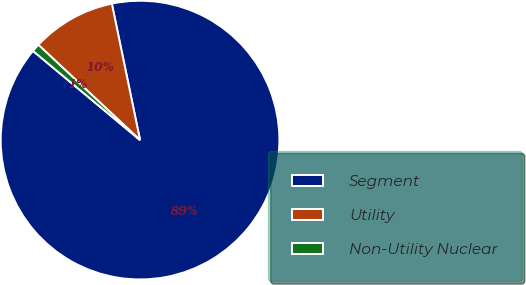Convert chart to OTSL. <chart><loc_0><loc_0><loc_500><loc_500><pie_chart><fcel>Segment<fcel>Utility<fcel>Non-Utility Nuclear<nl><fcel>89.3%<fcel>9.77%<fcel>0.93%<nl></chart> 